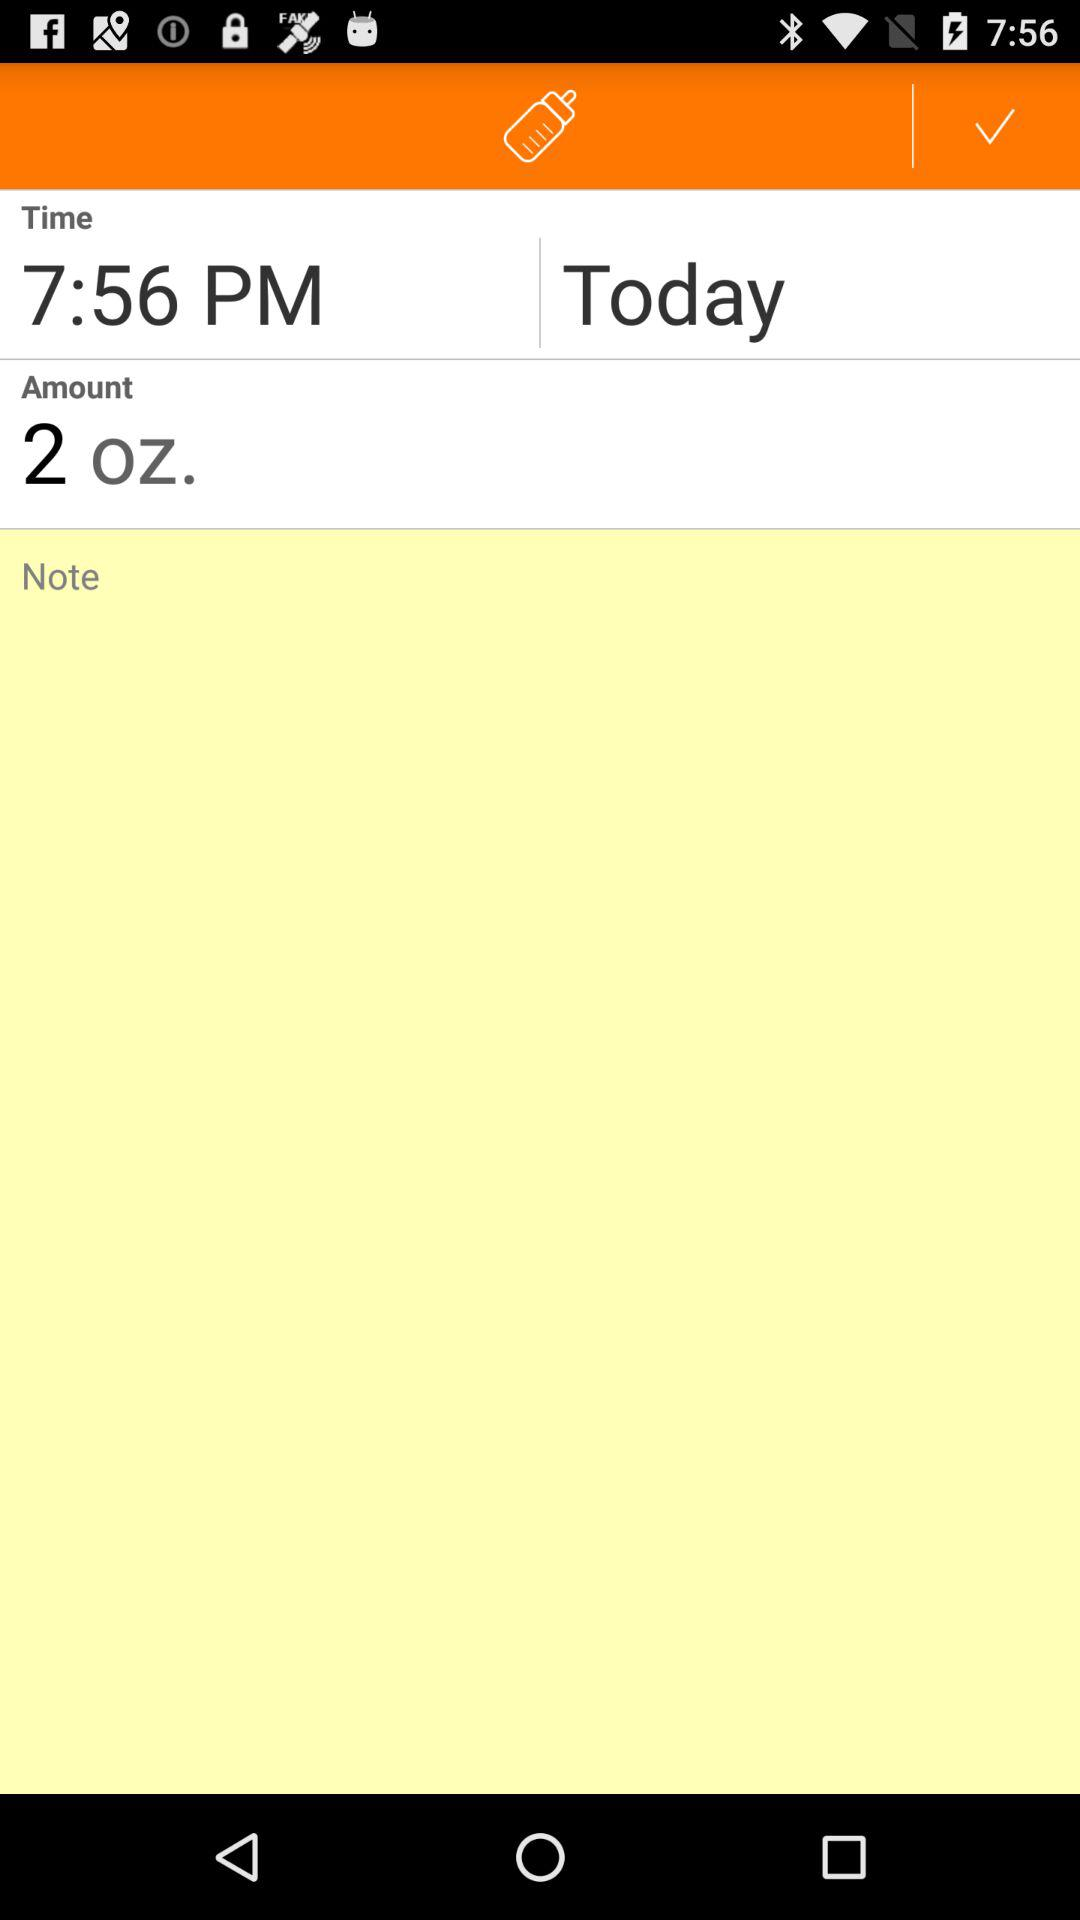What is the selected time for today? The selected time for today is 7:56 p.m. 